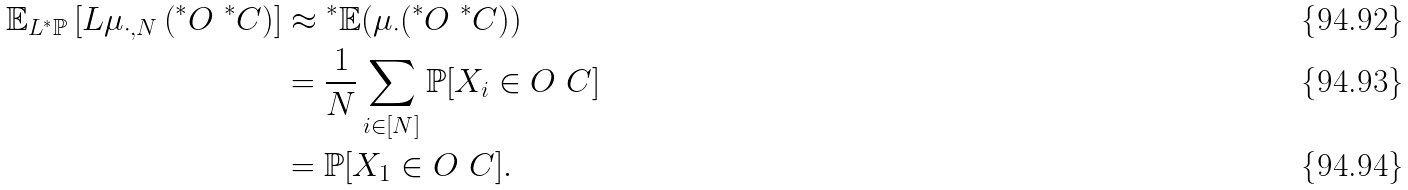Convert formula to latex. <formula><loc_0><loc_0><loc_500><loc_500>\mathbb { E } _ { L { ^ { * } } \mathbb { P } } \left [ L \mu _ { \cdot , N } \left ( { ^ { * } } O \ { ^ { * } } C \right ) \right ] & \approx { ^ { * } } \mathbb { E } ( \mu _ { \cdot } ( { ^ { * } } O \ { ^ { * } } C ) ) \\ & = \frac { 1 } { N } \sum _ { i \in [ N ] } \mathbb { P } [ X _ { i } \in O \ C ] \\ & = \mathbb { P } [ X _ { 1 } \in O \ C ] .</formula> 